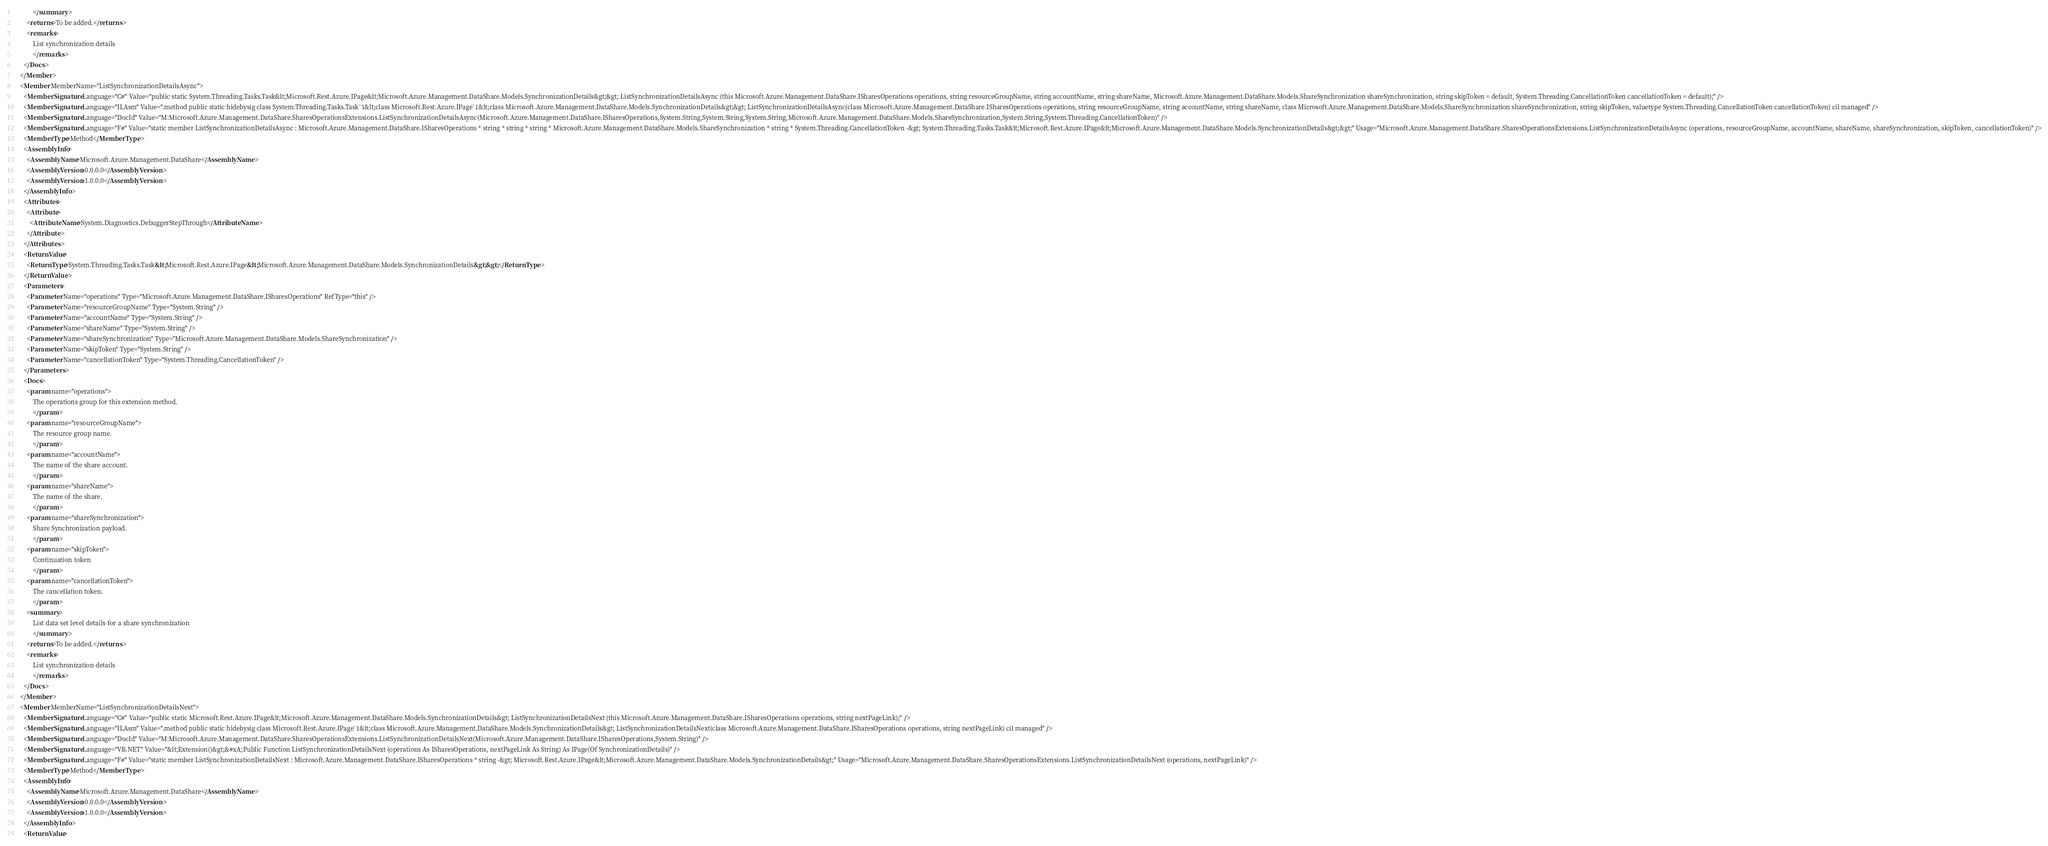<code> <loc_0><loc_0><loc_500><loc_500><_XML_>            </summary>
        <returns>To be added.</returns>
        <remarks>
            List synchronization details
            </remarks>
      </Docs>
    </Member>
    <Member MemberName="ListSynchronizationDetailsAsync">
      <MemberSignature Language="C#" Value="public static System.Threading.Tasks.Task&lt;Microsoft.Rest.Azure.IPage&lt;Microsoft.Azure.Management.DataShare.Models.SynchronizationDetails&gt;&gt; ListSynchronizationDetailsAsync (this Microsoft.Azure.Management.DataShare.ISharesOperations operations, string resourceGroupName, string accountName, string shareName, Microsoft.Azure.Management.DataShare.Models.ShareSynchronization shareSynchronization, string skipToken = default, System.Threading.CancellationToken cancellationToken = default);" />
      <MemberSignature Language="ILAsm" Value=".method public static hidebysig class System.Threading.Tasks.Task`1&lt;class Microsoft.Rest.Azure.IPage`1&lt;class Microsoft.Azure.Management.DataShare.Models.SynchronizationDetails&gt;&gt; ListSynchronizationDetailsAsync(class Microsoft.Azure.Management.DataShare.ISharesOperations operations, string resourceGroupName, string accountName, string shareName, class Microsoft.Azure.Management.DataShare.Models.ShareSynchronization shareSynchronization, string skipToken, valuetype System.Threading.CancellationToken cancellationToken) cil managed" />
      <MemberSignature Language="DocId" Value="M:Microsoft.Azure.Management.DataShare.SharesOperationsExtensions.ListSynchronizationDetailsAsync(Microsoft.Azure.Management.DataShare.ISharesOperations,System.String,System.String,System.String,Microsoft.Azure.Management.DataShare.Models.ShareSynchronization,System.String,System.Threading.CancellationToken)" />
      <MemberSignature Language="F#" Value="static member ListSynchronizationDetailsAsync : Microsoft.Azure.Management.DataShare.ISharesOperations * string * string * string * Microsoft.Azure.Management.DataShare.Models.ShareSynchronization * string * System.Threading.CancellationToken -&gt; System.Threading.Tasks.Task&lt;Microsoft.Rest.Azure.IPage&lt;Microsoft.Azure.Management.DataShare.Models.SynchronizationDetails&gt;&gt;" Usage="Microsoft.Azure.Management.DataShare.SharesOperationsExtensions.ListSynchronizationDetailsAsync (operations, resourceGroupName, accountName, shareName, shareSynchronization, skipToken, cancellationToken)" />
      <MemberType>Method</MemberType>
      <AssemblyInfo>
        <AssemblyName>Microsoft.Azure.Management.DataShare</AssemblyName>
        <AssemblyVersion>0.0.0.0</AssemblyVersion>
        <AssemblyVersion>1.0.0.0</AssemblyVersion>
      </AssemblyInfo>
      <Attributes>
        <Attribute>
          <AttributeName>System.Diagnostics.DebuggerStepThrough</AttributeName>
        </Attribute>
      </Attributes>
      <ReturnValue>
        <ReturnType>System.Threading.Tasks.Task&lt;Microsoft.Rest.Azure.IPage&lt;Microsoft.Azure.Management.DataShare.Models.SynchronizationDetails&gt;&gt;</ReturnType>
      </ReturnValue>
      <Parameters>
        <Parameter Name="operations" Type="Microsoft.Azure.Management.DataShare.ISharesOperations" RefType="this" />
        <Parameter Name="resourceGroupName" Type="System.String" />
        <Parameter Name="accountName" Type="System.String" />
        <Parameter Name="shareName" Type="System.String" />
        <Parameter Name="shareSynchronization" Type="Microsoft.Azure.Management.DataShare.Models.ShareSynchronization" />
        <Parameter Name="skipToken" Type="System.String" />
        <Parameter Name="cancellationToken" Type="System.Threading.CancellationToken" />
      </Parameters>
      <Docs>
        <param name="operations">
            The operations group for this extension method.
            </param>
        <param name="resourceGroupName">
            The resource group name.
            </param>
        <param name="accountName">
            The name of the share account.
            </param>
        <param name="shareName">
            The name of the share.
            </param>
        <param name="shareSynchronization">
            Share Synchronization payload.
            </param>
        <param name="skipToken">
            Continuation token
            </param>
        <param name="cancellationToken">
            The cancellation token.
            </param>
        <summary>
            List data set level details for a share synchronization
            </summary>
        <returns>To be added.</returns>
        <remarks>
            List synchronization details
            </remarks>
      </Docs>
    </Member>
    <Member MemberName="ListSynchronizationDetailsNext">
      <MemberSignature Language="C#" Value="public static Microsoft.Rest.Azure.IPage&lt;Microsoft.Azure.Management.DataShare.Models.SynchronizationDetails&gt; ListSynchronizationDetailsNext (this Microsoft.Azure.Management.DataShare.ISharesOperations operations, string nextPageLink);" />
      <MemberSignature Language="ILAsm" Value=".method public static hidebysig class Microsoft.Rest.Azure.IPage`1&lt;class Microsoft.Azure.Management.DataShare.Models.SynchronizationDetails&gt; ListSynchronizationDetailsNext(class Microsoft.Azure.Management.DataShare.ISharesOperations operations, string nextPageLink) cil managed" />
      <MemberSignature Language="DocId" Value="M:Microsoft.Azure.Management.DataShare.SharesOperationsExtensions.ListSynchronizationDetailsNext(Microsoft.Azure.Management.DataShare.ISharesOperations,System.String)" />
      <MemberSignature Language="VB.NET" Value="&lt;Extension()&gt;&#xA;Public Function ListSynchronizationDetailsNext (operations As ISharesOperations, nextPageLink As String) As IPage(Of SynchronizationDetails)" />
      <MemberSignature Language="F#" Value="static member ListSynchronizationDetailsNext : Microsoft.Azure.Management.DataShare.ISharesOperations * string -&gt; Microsoft.Rest.Azure.IPage&lt;Microsoft.Azure.Management.DataShare.Models.SynchronizationDetails&gt;" Usage="Microsoft.Azure.Management.DataShare.SharesOperationsExtensions.ListSynchronizationDetailsNext (operations, nextPageLink)" />
      <MemberType>Method</MemberType>
      <AssemblyInfo>
        <AssemblyName>Microsoft.Azure.Management.DataShare</AssemblyName>
        <AssemblyVersion>0.0.0.0</AssemblyVersion>
        <AssemblyVersion>1.0.0.0</AssemblyVersion>
      </AssemblyInfo>
      <ReturnValue></code> 